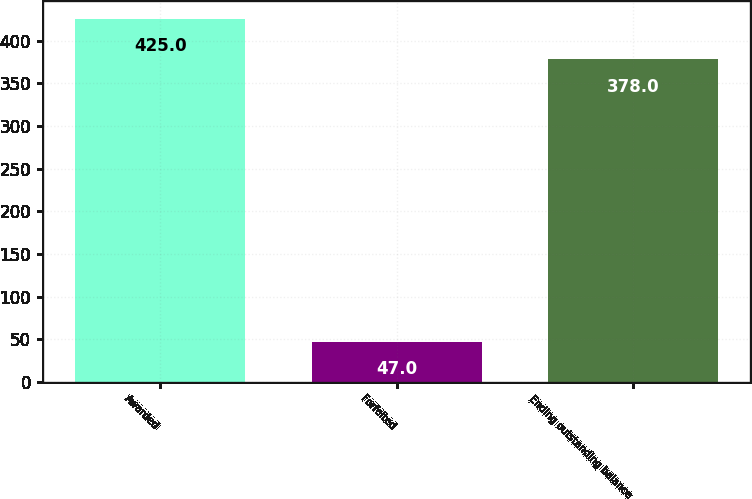<chart> <loc_0><loc_0><loc_500><loc_500><bar_chart><fcel>Awarded<fcel>Forfeited<fcel>Ending outstanding balance<nl><fcel>425<fcel>47<fcel>378<nl></chart> 